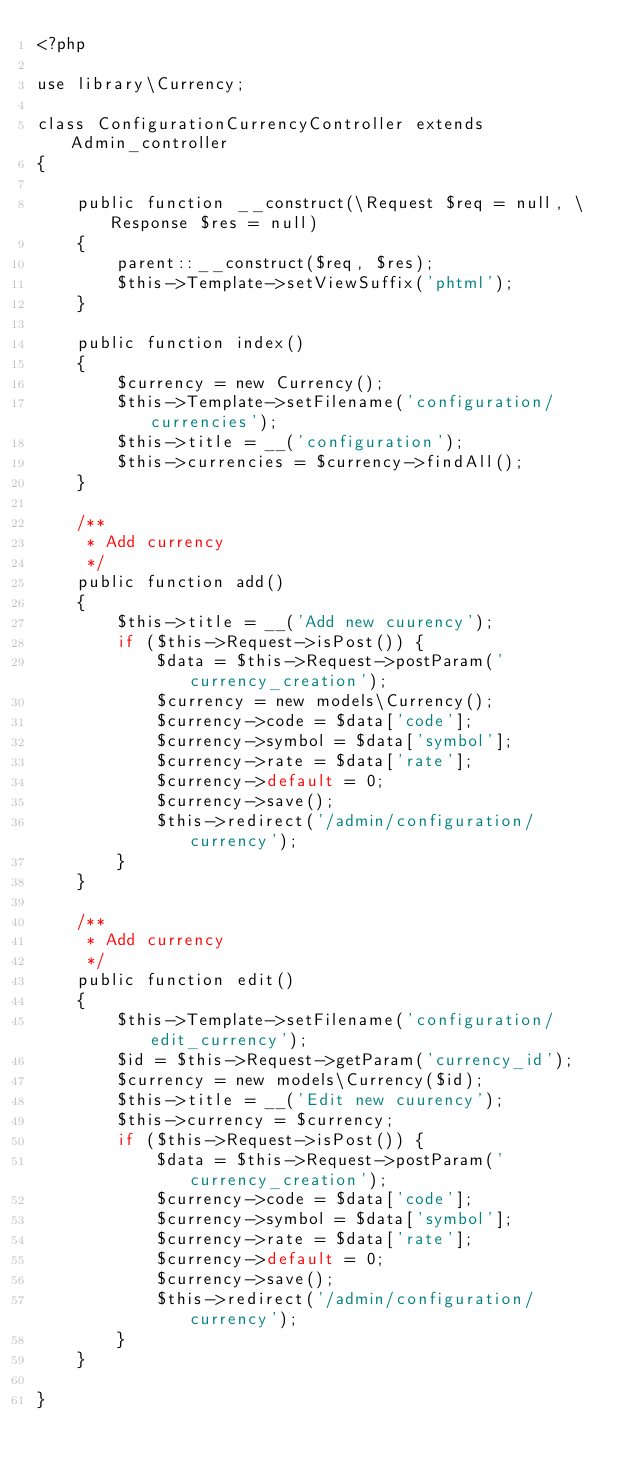<code> <loc_0><loc_0><loc_500><loc_500><_PHP_><?php

use library\Currency;

class ConfigurationCurrencyController extends Admin_controller
{

    public function __construct(\Request $req = null, \Response $res = null)
    {
        parent::__construct($req, $res);
        $this->Template->setViewSuffix('phtml');
    }

    public function index()
    {
        $currency = new Currency();
        $this->Template->setFilename('configuration/currencies');
        $this->title = __('configuration');
        $this->currencies = $currency->findAll();
    }
    
    /**
     * Add currency
     */
    public function add() 
    {
        $this->title = __('Add new cuurency');
        if ($this->Request->isPost()) {
            $data = $this->Request->postParam('currency_creation');
            $currency = new models\Currency();
            $currency->code = $data['code'];
            $currency->symbol = $data['symbol'];
            $currency->rate = $data['rate'];
            $currency->default = 0;            
            $currency->save();
            $this->redirect('/admin/configuration/currency');
        }
    }
    
    /**
     * Add currency
     */
    public function edit() 
    {
        $this->Template->setFilename('configuration/edit_currency');
        $id = $this->Request->getParam('currency_id');
        $currency = new models\Currency($id);
        $this->title = __('Edit new cuurency');
        $this->currency = $currency;
        if ($this->Request->isPost()) {
            $data = $this->Request->postParam('currency_creation');            
            $currency->code = $data['code'];
            $currency->symbol = $data['symbol'];
            $currency->rate = $data['rate'];
            $currency->default = 0;            
            $currency->save();
            $this->redirect('/admin/configuration/currency');
        }
    }

}
</code> 